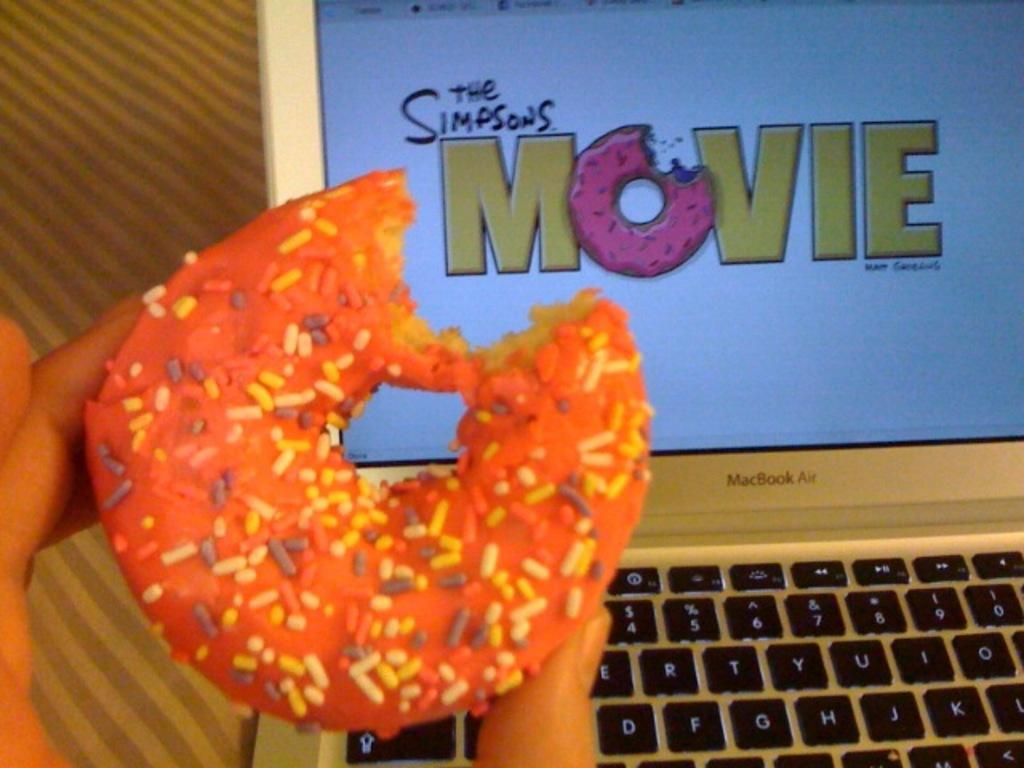What is the human hand in the image holding? The hand is holding a donut. What other object can be seen in the image? There is a laptop in the image. What letter is being measured by the human hand in the image? There is no letter present in the image, and the hand is holding a donut, not measuring anything. 